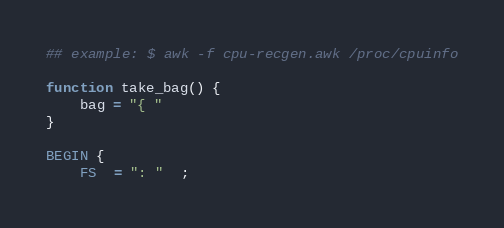<code> <loc_0><loc_0><loc_500><loc_500><_Awk_>## example: $ awk -f cpu-recgen.awk /proc/cpuinfo

function take_bag() {
    bag = "{ "
}

BEGIN {
    FS  = ": "  ;</code> 